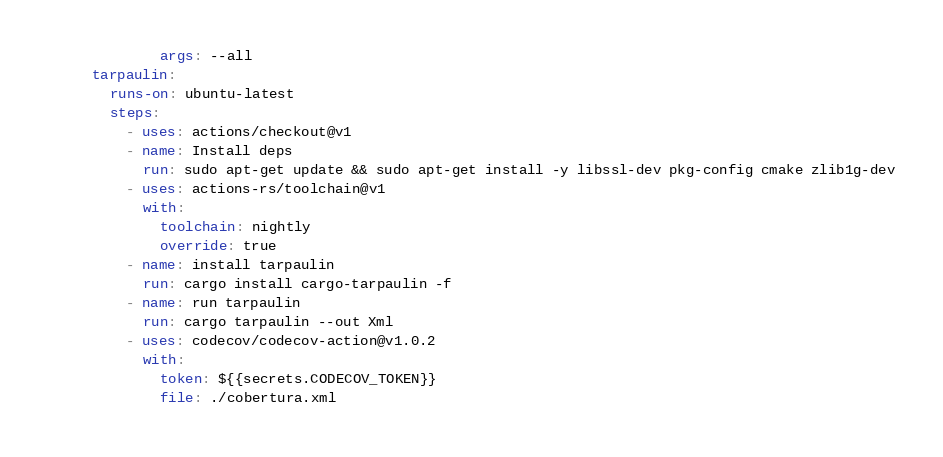<code> <loc_0><loc_0><loc_500><loc_500><_YAML_>          args: --all
  tarpaulin:
    runs-on: ubuntu-latest
    steps:
      - uses: actions/checkout@v1
      - name: Install deps
        run: sudo apt-get update && sudo apt-get install -y libssl-dev pkg-config cmake zlib1g-dev
      - uses: actions-rs/toolchain@v1
        with:
          toolchain: nightly
          override: true
      - name: install tarpaulin
        run: cargo install cargo-tarpaulin -f
      - name: run tarpaulin
        run: cargo tarpaulin --out Xml 
      - uses: codecov/codecov-action@v1.0.2
        with:
          token: ${{secrets.CODECOV_TOKEN}}
          file: ./cobertura.xml     </code> 